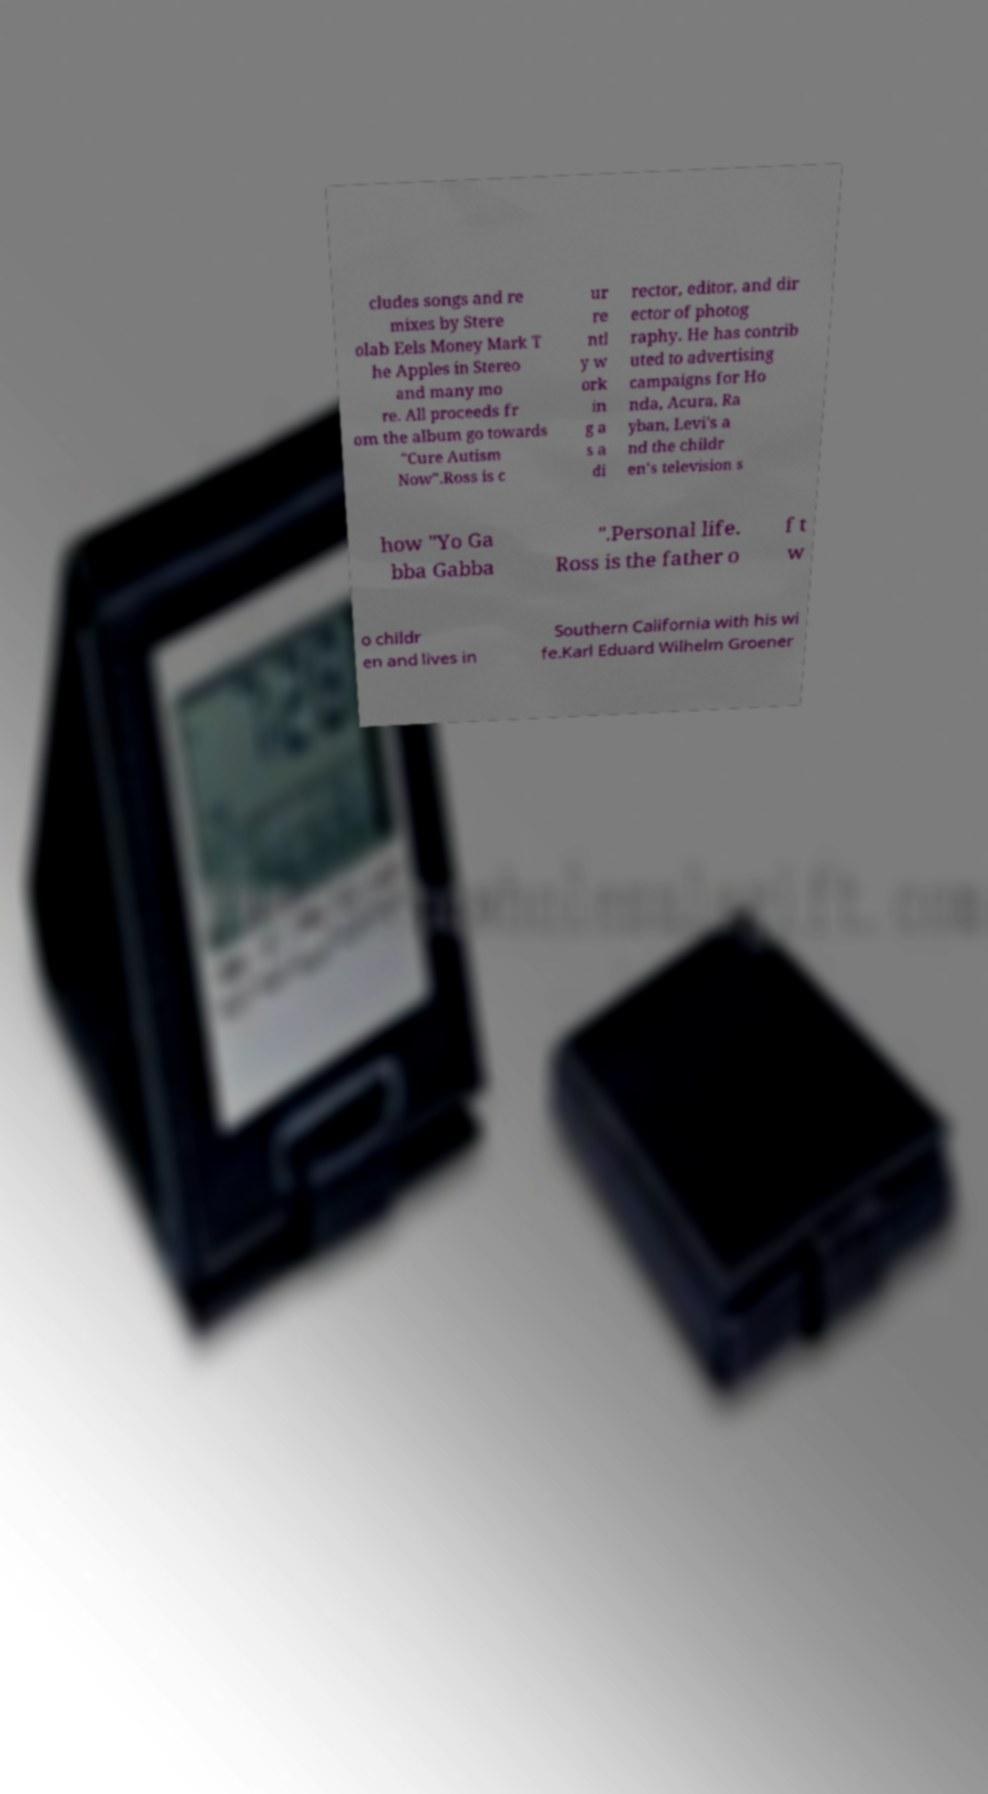For documentation purposes, I need the text within this image transcribed. Could you provide that? cludes songs and re mixes by Stere olab Eels Money Mark T he Apples in Stereo and many mo re. All proceeds fr om the album go towards "Cure Autism Now".Ross is c ur re ntl y w ork in g a s a di rector, editor, and dir ector of photog raphy. He has contrib uted to advertising campaigns for Ho nda, Acura, Ra yban, Levi's a nd the childr en's television s how "Yo Ga bba Gabba ".Personal life. Ross is the father o f t w o childr en and lives in Southern California with his wi fe.Karl Eduard Wilhelm Groener 